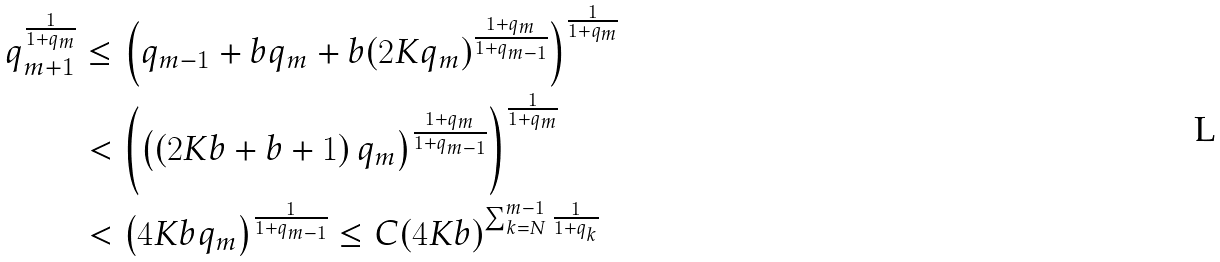<formula> <loc_0><loc_0><loc_500><loc_500>q _ { m + 1 } ^ { \frac { 1 } { 1 + q _ { m } } } & \leq \left ( q _ { m - 1 } + b q _ { m } + b ( 2 K q _ { m } ) ^ { \frac { 1 + q _ { m } } { 1 + q _ { m - 1 } } } \right ) ^ { \frac { 1 } { 1 + q _ { m } } } \\ & < \left ( \left ( \left ( 2 K b + b + 1 \right ) q _ { m } \right ) ^ { \frac { 1 + q _ { m } } { 1 + q _ { m - 1 } } } \right ) ^ { \frac { 1 } { 1 + q _ { m } } } \\ & < \left ( 4 K b q _ { m } \right ) ^ { \frac { 1 } { 1 + q _ { m - 1 } } } \leq C ( 4 K b ) ^ { \sum _ { k = N } ^ { m - 1 } \frac { 1 } { 1 + q _ { k } } }</formula> 